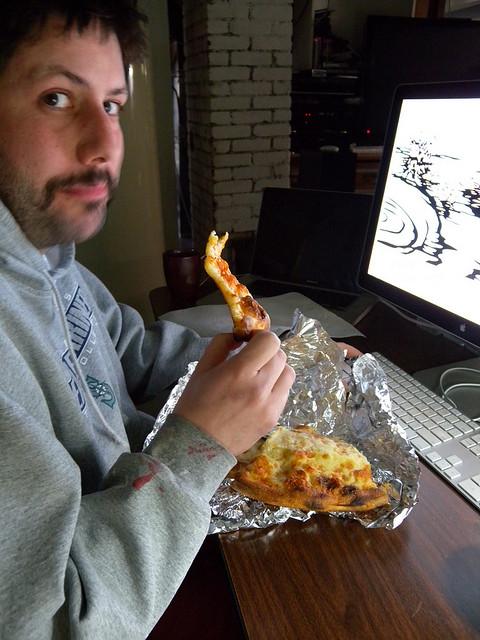What kind of food is shown?
Write a very short answer. Pizza. Is he wearing a hoodie?
Quick response, please. Yes. What is this man eating?
Quick response, please. Pizza. 